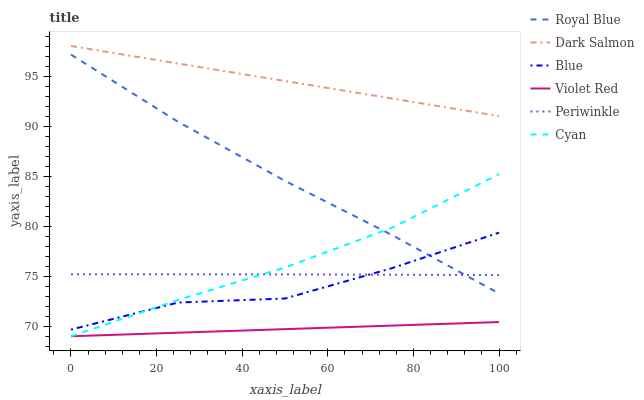Does Dark Salmon have the minimum area under the curve?
Answer yes or no. No. Does Violet Red have the maximum area under the curve?
Answer yes or no. No. Is Violet Red the smoothest?
Answer yes or no. No. Is Violet Red the roughest?
Answer yes or no. No. Does Dark Salmon have the lowest value?
Answer yes or no. No. Does Violet Red have the highest value?
Answer yes or no. No. Is Violet Red less than Periwinkle?
Answer yes or no. Yes. Is Dark Salmon greater than Violet Red?
Answer yes or no. Yes. Does Violet Red intersect Periwinkle?
Answer yes or no. No. 